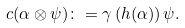<formula> <loc_0><loc_0><loc_500><loc_500>c ( \alpha \otimes \psi ) & \colon = \gamma \left ( h ( \alpha ) \right ) \psi .</formula> 